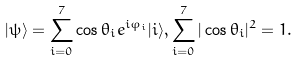<formula> <loc_0><loc_0><loc_500><loc_500>| \psi \rangle = \sum ^ { 7 } _ { i = 0 } \cos \theta _ { i } e ^ { i \varphi _ { i } } | i \rangle , \sum _ { i = 0 } ^ { 7 } | \cos \theta _ { i } | ^ { 2 } = 1 .</formula> 